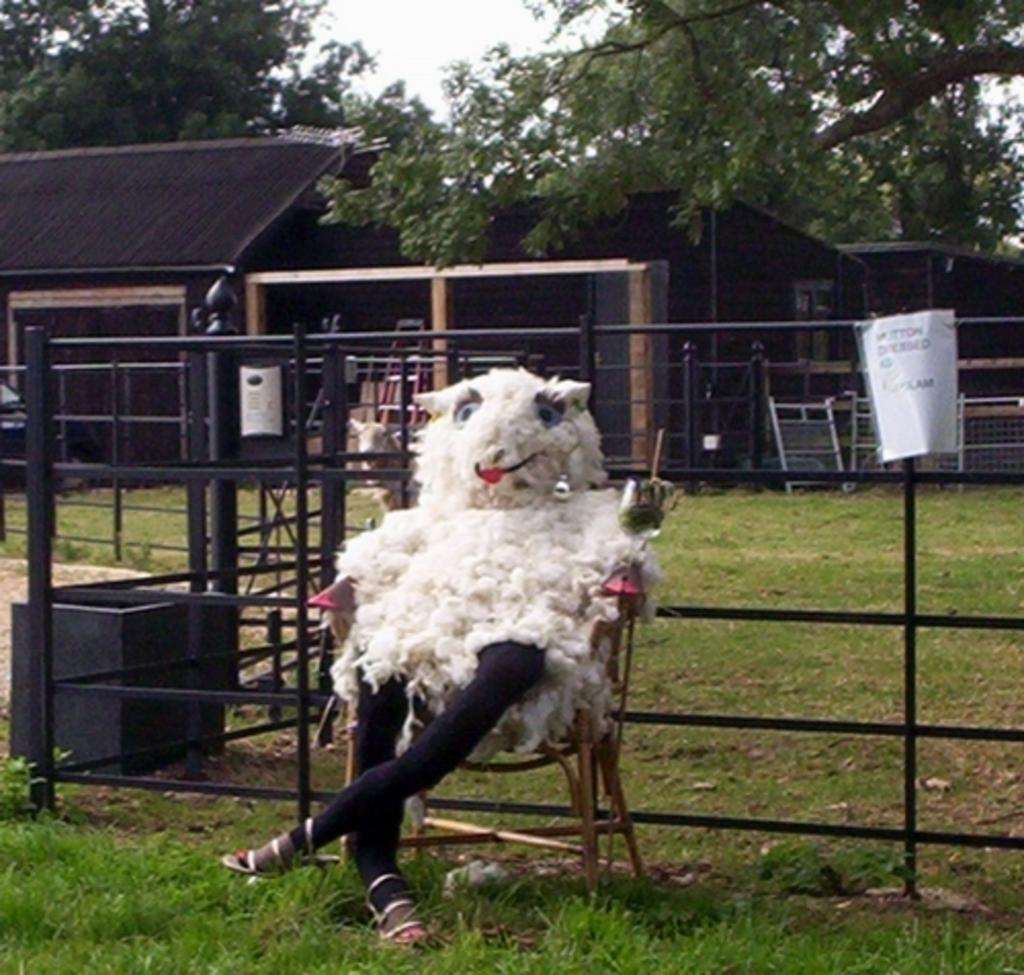What is the person in the image doing? The person is sitting in a chair in the image. What type of clothing is the person wearing? The person is wearing animal fur. What type of natural environment is visible at the bottom of the image? There is grass at the bottom of the image. What type of structure can be seen in the background of the image? There is a small house in the background of the image. What type of vegetation is visible at the top of the image? There are trees at the top of the image. What type of collar is the person wearing in the image? There is no collar visible in the image; the person is wearing animal fur. What type of apparel is the person wearing in the room? The image does not show a room, and the person is wearing animal fur, not apparel. 